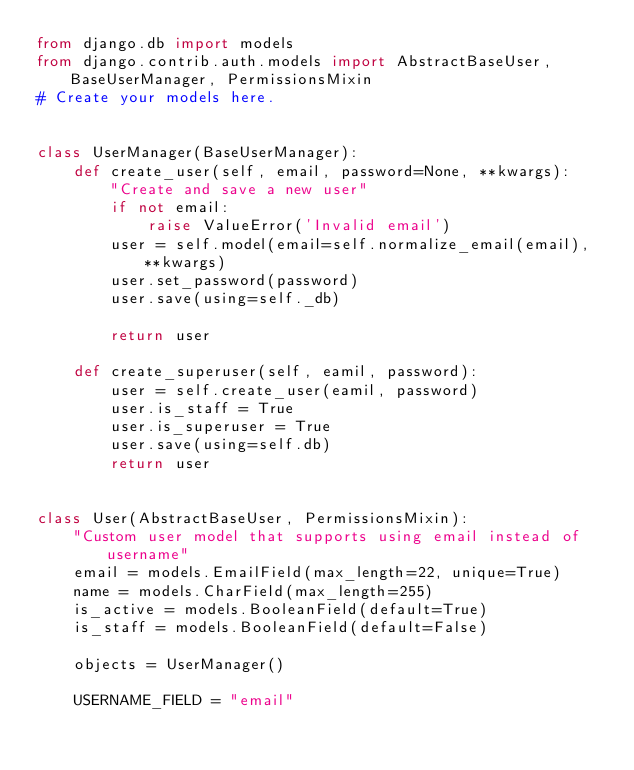<code> <loc_0><loc_0><loc_500><loc_500><_Python_>from django.db import models
from django.contrib.auth.models import AbstractBaseUser, BaseUserManager, PermissionsMixin
# Create your models here.


class UserManager(BaseUserManager):
    def create_user(self, email, password=None, **kwargs):
        "Create and save a new user"
        if not email:
            raise ValueError('Invalid email')
        user = self.model(email=self.normalize_email(email), **kwargs)
        user.set_password(password)
        user.save(using=self._db)

        return user

    def create_superuser(self, eamil, password):
        user = self.create_user(eamil, password)
        user.is_staff = True
        user.is_superuser = True
        user.save(using=self.db)
        return user


class User(AbstractBaseUser, PermissionsMixin):
    "Custom user model that supports using email instead of username"
    email = models.EmailField(max_length=22, unique=True)
    name = models.CharField(max_length=255)
    is_active = models.BooleanField(default=True)
    is_staff = models.BooleanField(default=False)

    objects = UserManager()

    USERNAME_FIELD = "email"
</code> 